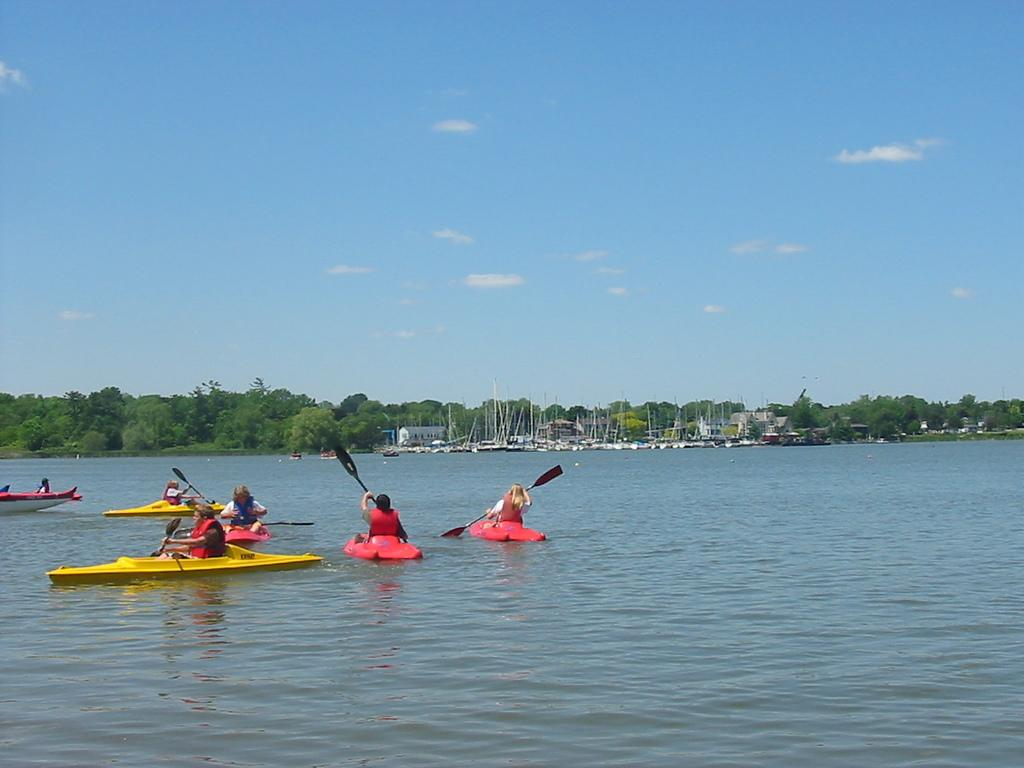What is happening on the water surface in the image? There are boats sailing on the water surface in the image. What can be seen in the background of the image? There are trees visible in the background of the image. Are there any other boats in the image besides the ones sailing on the water surface? Yes, there are additional boats in the background of the image. What type of stove is visible in the image? There is no stove present in the image; it features boats sailing on the water surface and trees in the background. Can you describe the skateboarding skills of the people in the image? There is no skateboarding or people visible in the image; it only shows boats sailing on the water surface and trees in the background. 